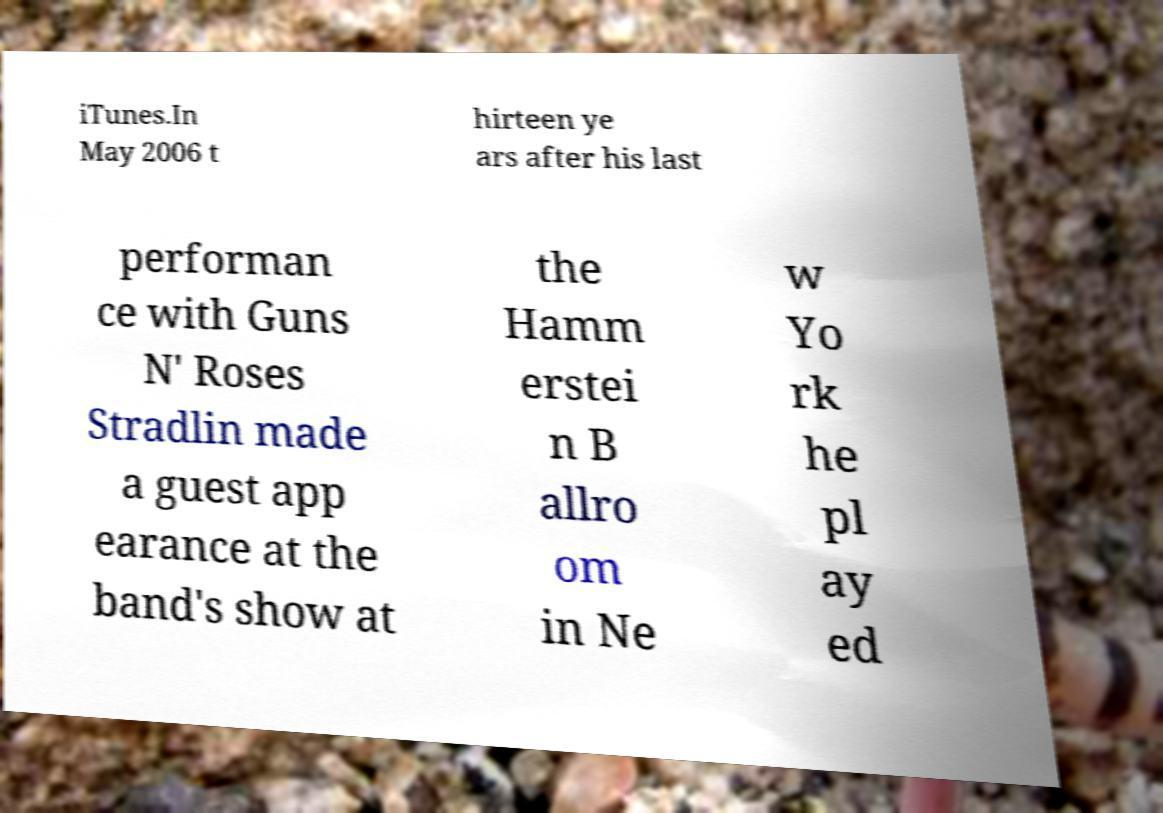Can you read and provide the text displayed in the image?This photo seems to have some interesting text. Can you extract and type it out for me? iTunes.In May 2006 t hirteen ye ars after his last performan ce with Guns N' Roses Stradlin made a guest app earance at the band's show at the Hamm erstei n B allro om in Ne w Yo rk he pl ay ed 